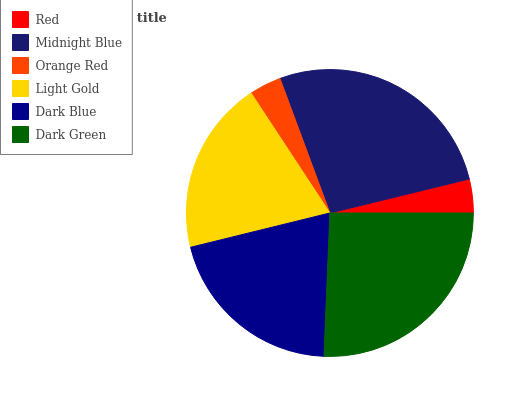Is Orange Red the minimum?
Answer yes or no. Yes. Is Midnight Blue the maximum?
Answer yes or no. Yes. Is Midnight Blue the minimum?
Answer yes or no. No. Is Orange Red the maximum?
Answer yes or no. No. Is Midnight Blue greater than Orange Red?
Answer yes or no. Yes. Is Orange Red less than Midnight Blue?
Answer yes or no. Yes. Is Orange Red greater than Midnight Blue?
Answer yes or no. No. Is Midnight Blue less than Orange Red?
Answer yes or no. No. Is Dark Blue the high median?
Answer yes or no. Yes. Is Light Gold the low median?
Answer yes or no. Yes. Is Dark Green the high median?
Answer yes or no. No. Is Dark Blue the low median?
Answer yes or no. No. 